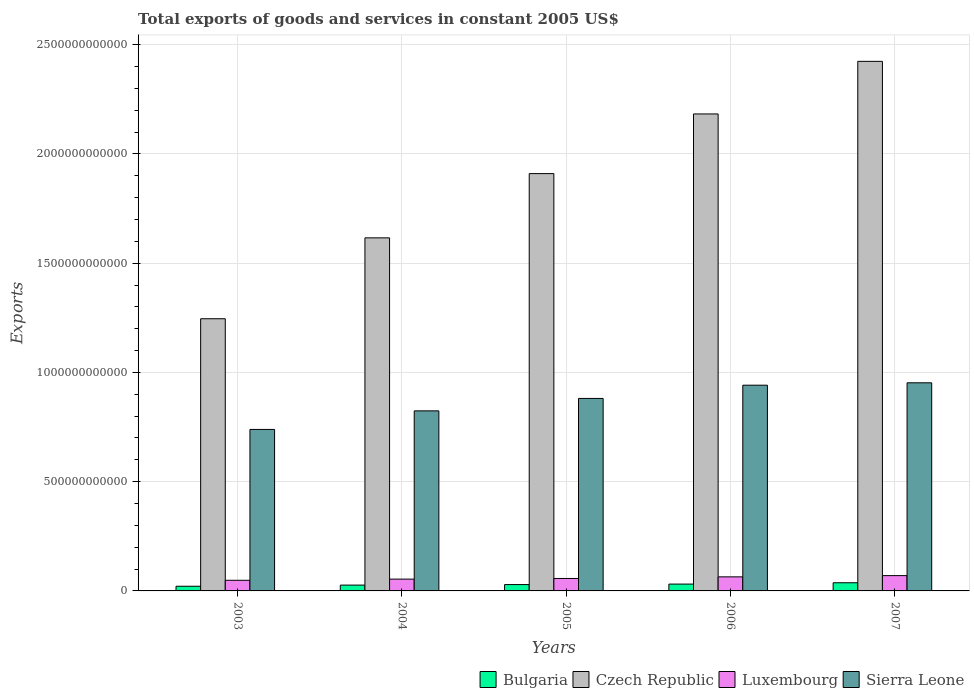How many different coloured bars are there?
Your answer should be compact. 4. How many groups of bars are there?
Make the answer very short. 5. Are the number of bars per tick equal to the number of legend labels?
Make the answer very short. Yes. Are the number of bars on each tick of the X-axis equal?
Give a very brief answer. Yes. How many bars are there on the 1st tick from the left?
Provide a succinct answer. 4. What is the label of the 5th group of bars from the left?
Make the answer very short. 2007. In how many cases, is the number of bars for a given year not equal to the number of legend labels?
Your answer should be compact. 0. What is the total exports of goods and services in Luxembourg in 2006?
Provide a succinct answer. 6.44e+1. Across all years, what is the maximum total exports of goods and services in Bulgaria?
Offer a very short reply. 3.74e+1. Across all years, what is the minimum total exports of goods and services in Bulgaria?
Give a very brief answer. 2.14e+1. In which year was the total exports of goods and services in Sierra Leone maximum?
Provide a short and direct response. 2007. What is the total total exports of goods and services in Luxembourg in the graph?
Keep it short and to the point. 2.94e+11. What is the difference between the total exports of goods and services in Czech Republic in 2004 and that in 2007?
Make the answer very short. -8.08e+11. What is the difference between the total exports of goods and services in Bulgaria in 2005 and the total exports of goods and services in Luxembourg in 2003?
Offer a terse response. -1.97e+1. What is the average total exports of goods and services in Bulgaria per year?
Give a very brief answer. 2.91e+1. In the year 2004, what is the difference between the total exports of goods and services in Czech Republic and total exports of goods and services in Bulgaria?
Provide a short and direct response. 1.59e+12. What is the ratio of the total exports of goods and services in Bulgaria in 2003 to that in 2007?
Give a very brief answer. 0.57. Is the total exports of goods and services in Luxembourg in 2003 less than that in 2006?
Keep it short and to the point. Yes. Is the difference between the total exports of goods and services in Czech Republic in 2005 and 2006 greater than the difference between the total exports of goods and services in Bulgaria in 2005 and 2006?
Keep it short and to the point. No. What is the difference between the highest and the second highest total exports of goods and services in Luxembourg?
Keep it short and to the point. 5.70e+09. What is the difference between the highest and the lowest total exports of goods and services in Czech Republic?
Offer a terse response. 1.18e+12. In how many years, is the total exports of goods and services in Sierra Leone greater than the average total exports of goods and services in Sierra Leone taken over all years?
Your response must be concise. 3. What does the 3rd bar from the left in 2004 represents?
Provide a short and direct response. Luxembourg. Are all the bars in the graph horizontal?
Give a very brief answer. No. What is the difference between two consecutive major ticks on the Y-axis?
Ensure brevity in your answer.  5.00e+11. Are the values on the major ticks of Y-axis written in scientific E-notation?
Make the answer very short. No. Does the graph contain any zero values?
Offer a very short reply. No. Does the graph contain grids?
Offer a very short reply. Yes. How many legend labels are there?
Offer a terse response. 4. What is the title of the graph?
Your answer should be compact. Total exports of goods and services in constant 2005 US$. Does "Caribbean small states" appear as one of the legend labels in the graph?
Keep it short and to the point. No. What is the label or title of the Y-axis?
Your answer should be compact. Exports. What is the Exports in Bulgaria in 2003?
Make the answer very short. 2.14e+1. What is the Exports of Czech Republic in 2003?
Provide a short and direct response. 1.25e+12. What is the Exports of Luxembourg in 2003?
Your answer should be very brief. 4.87e+1. What is the Exports of Sierra Leone in 2003?
Ensure brevity in your answer.  7.39e+11. What is the Exports in Bulgaria in 2004?
Your answer should be very brief. 2.66e+1. What is the Exports in Czech Republic in 2004?
Ensure brevity in your answer.  1.62e+12. What is the Exports of Luxembourg in 2004?
Provide a short and direct response. 5.40e+1. What is the Exports of Sierra Leone in 2004?
Provide a succinct answer. 8.24e+11. What is the Exports in Bulgaria in 2005?
Keep it short and to the point. 2.90e+1. What is the Exports of Czech Republic in 2005?
Provide a succinct answer. 1.91e+12. What is the Exports in Luxembourg in 2005?
Your response must be concise. 5.70e+1. What is the Exports of Sierra Leone in 2005?
Offer a terse response. 8.81e+11. What is the Exports in Bulgaria in 2006?
Offer a very short reply. 3.13e+1. What is the Exports in Czech Republic in 2006?
Give a very brief answer. 2.18e+12. What is the Exports in Luxembourg in 2006?
Give a very brief answer. 6.44e+1. What is the Exports of Sierra Leone in 2006?
Provide a short and direct response. 9.42e+11. What is the Exports of Bulgaria in 2007?
Keep it short and to the point. 3.74e+1. What is the Exports in Czech Republic in 2007?
Give a very brief answer. 2.42e+12. What is the Exports in Luxembourg in 2007?
Provide a succinct answer. 7.01e+1. What is the Exports of Sierra Leone in 2007?
Offer a terse response. 9.53e+11. Across all years, what is the maximum Exports in Bulgaria?
Ensure brevity in your answer.  3.74e+1. Across all years, what is the maximum Exports of Czech Republic?
Offer a very short reply. 2.42e+12. Across all years, what is the maximum Exports of Luxembourg?
Offer a very short reply. 7.01e+1. Across all years, what is the maximum Exports in Sierra Leone?
Make the answer very short. 9.53e+11. Across all years, what is the minimum Exports in Bulgaria?
Offer a very short reply. 2.14e+1. Across all years, what is the minimum Exports in Czech Republic?
Make the answer very short. 1.25e+12. Across all years, what is the minimum Exports of Luxembourg?
Keep it short and to the point. 4.87e+1. Across all years, what is the minimum Exports in Sierra Leone?
Provide a short and direct response. 7.39e+11. What is the total Exports in Bulgaria in the graph?
Your response must be concise. 1.46e+11. What is the total Exports in Czech Republic in the graph?
Provide a short and direct response. 9.38e+12. What is the total Exports of Luxembourg in the graph?
Make the answer very short. 2.94e+11. What is the total Exports of Sierra Leone in the graph?
Give a very brief answer. 4.34e+12. What is the difference between the Exports in Bulgaria in 2003 and that in 2004?
Your answer should be very brief. -5.24e+09. What is the difference between the Exports in Czech Republic in 2003 and that in 2004?
Your response must be concise. -3.70e+11. What is the difference between the Exports of Luxembourg in 2003 and that in 2004?
Keep it short and to the point. -5.30e+09. What is the difference between the Exports in Sierra Leone in 2003 and that in 2004?
Provide a succinct answer. -8.50e+1. What is the difference between the Exports in Bulgaria in 2003 and that in 2005?
Keep it short and to the point. -7.66e+09. What is the difference between the Exports in Czech Republic in 2003 and that in 2005?
Your answer should be very brief. -6.64e+11. What is the difference between the Exports in Luxembourg in 2003 and that in 2005?
Your answer should be compact. -8.27e+09. What is the difference between the Exports in Sierra Leone in 2003 and that in 2005?
Your answer should be compact. -1.42e+11. What is the difference between the Exports of Bulgaria in 2003 and that in 2006?
Ensure brevity in your answer.  -9.88e+09. What is the difference between the Exports of Czech Republic in 2003 and that in 2006?
Your answer should be very brief. -9.37e+11. What is the difference between the Exports of Luxembourg in 2003 and that in 2006?
Provide a short and direct response. -1.57e+1. What is the difference between the Exports of Sierra Leone in 2003 and that in 2006?
Your response must be concise. -2.03e+11. What is the difference between the Exports in Bulgaria in 2003 and that in 2007?
Offer a very short reply. -1.60e+1. What is the difference between the Exports in Czech Republic in 2003 and that in 2007?
Give a very brief answer. -1.18e+12. What is the difference between the Exports of Luxembourg in 2003 and that in 2007?
Offer a terse response. -2.14e+1. What is the difference between the Exports in Sierra Leone in 2003 and that in 2007?
Provide a short and direct response. -2.13e+11. What is the difference between the Exports in Bulgaria in 2004 and that in 2005?
Make the answer very short. -2.42e+09. What is the difference between the Exports of Czech Republic in 2004 and that in 2005?
Offer a terse response. -2.94e+11. What is the difference between the Exports in Luxembourg in 2004 and that in 2005?
Your answer should be compact. -2.97e+09. What is the difference between the Exports of Sierra Leone in 2004 and that in 2005?
Offer a very short reply. -5.69e+1. What is the difference between the Exports in Bulgaria in 2004 and that in 2006?
Your answer should be very brief. -4.64e+09. What is the difference between the Exports in Czech Republic in 2004 and that in 2006?
Provide a short and direct response. -5.67e+11. What is the difference between the Exports in Luxembourg in 2004 and that in 2006?
Provide a succinct answer. -1.04e+1. What is the difference between the Exports of Sierra Leone in 2004 and that in 2006?
Give a very brief answer. -1.17e+11. What is the difference between the Exports of Bulgaria in 2004 and that in 2007?
Provide a short and direct response. -1.08e+1. What is the difference between the Exports in Czech Republic in 2004 and that in 2007?
Keep it short and to the point. -8.08e+11. What is the difference between the Exports in Luxembourg in 2004 and that in 2007?
Make the answer very short. -1.61e+1. What is the difference between the Exports in Sierra Leone in 2004 and that in 2007?
Your response must be concise. -1.28e+11. What is the difference between the Exports of Bulgaria in 2005 and that in 2006?
Offer a very short reply. -2.23e+09. What is the difference between the Exports of Czech Republic in 2005 and that in 2006?
Provide a succinct answer. -2.73e+11. What is the difference between the Exports of Luxembourg in 2005 and that in 2006?
Ensure brevity in your answer.  -7.42e+09. What is the difference between the Exports of Sierra Leone in 2005 and that in 2006?
Make the answer very short. -6.06e+1. What is the difference between the Exports in Bulgaria in 2005 and that in 2007?
Give a very brief answer. -8.36e+09. What is the difference between the Exports of Czech Republic in 2005 and that in 2007?
Keep it short and to the point. -5.14e+11. What is the difference between the Exports in Luxembourg in 2005 and that in 2007?
Your answer should be compact. -1.31e+1. What is the difference between the Exports of Sierra Leone in 2005 and that in 2007?
Offer a very short reply. -7.16e+1. What is the difference between the Exports in Bulgaria in 2006 and that in 2007?
Ensure brevity in your answer.  -6.13e+09. What is the difference between the Exports of Czech Republic in 2006 and that in 2007?
Your response must be concise. -2.41e+11. What is the difference between the Exports of Luxembourg in 2006 and that in 2007?
Make the answer very short. -5.70e+09. What is the difference between the Exports in Sierra Leone in 2006 and that in 2007?
Your response must be concise. -1.10e+1. What is the difference between the Exports of Bulgaria in 2003 and the Exports of Czech Republic in 2004?
Your answer should be very brief. -1.59e+12. What is the difference between the Exports in Bulgaria in 2003 and the Exports in Luxembourg in 2004?
Your answer should be compact. -3.26e+1. What is the difference between the Exports in Bulgaria in 2003 and the Exports in Sierra Leone in 2004?
Provide a succinct answer. -8.03e+11. What is the difference between the Exports of Czech Republic in 2003 and the Exports of Luxembourg in 2004?
Make the answer very short. 1.19e+12. What is the difference between the Exports in Czech Republic in 2003 and the Exports in Sierra Leone in 2004?
Make the answer very short. 4.22e+11. What is the difference between the Exports in Luxembourg in 2003 and the Exports in Sierra Leone in 2004?
Provide a short and direct response. -7.76e+11. What is the difference between the Exports in Bulgaria in 2003 and the Exports in Czech Republic in 2005?
Your answer should be very brief. -1.89e+12. What is the difference between the Exports in Bulgaria in 2003 and the Exports in Luxembourg in 2005?
Provide a succinct answer. -3.56e+1. What is the difference between the Exports in Bulgaria in 2003 and the Exports in Sierra Leone in 2005?
Offer a very short reply. -8.60e+11. What is the difference between the Exports of Czech Republic in 2003 and the Exports of Luxembourg in 2005?
Your answer should be compact. 1.19e+12. What is the difference between the Exports of Czech Republic in 2003 and the Exports of Sierra Leone in 2005?
Make the answer very short. 3.65e+11. What is the difference between the Exports of Luxembourg in 2003 and the Exports of Sierra Leone in 2005?
Make the answer very short. -8.32e+11. What is the difference between the Exports in Bulgaria in 2003 and the Exports in Czech Republic in 2006?
Your answer should be compact. -2.16e+12. What is the difference between the Exports in Bulgaria in 2003 and the Exports in Luxembourg in 2006?
Your answer should be very brief. -4.30e+1. What is the difference between the Exports of Bulgaria in 2003 and the Exports of Sierra Leone in 2006?
Offer a very short reply. -9.20e+11. What is the difference between the Exports in Czech Republic in 2003 and the Exports in Luxembourg in 2006?
Your answer should be very brief. 1.18e+12. What is the difference between the Exports of Czech Republic in 2003 and the Exports of Sierra Leone in 2006?
Your answer should be compact. 3.04e+11. What is the difference between the Exports of Luxembourg in 2003 and the Exports of Sierra Leone in 2006?
Your answer should be compact. -8.93e+11. What is the difference between the Exports of Bulgaria in 2003 and the Exports of Czech Republic in 2007?
Your answer should be compact. -2.40e+12. What is the difference between the Exports in Bulgaria in 2003 and the Exports in Luxembourg in 2007?
Offer a very short reply. -4.87e+1. What is the difference between the Exports of Bulgaria in 2003 and the Exports of Sierra Leone in 2007?
Provide a succinct answer. -9.31e+11. What is the difference between the Exports in Czech Republic in 2003 and the Exports in Luxembourg in 2007?
Give a very brief answer. 1.18e+12. What is the difference between the Exports of Czech Republic in 2003 and the Exports of Sierra Leone in 2007?
Make the answer very short. 2.93e+11. What is the difference between the Exports of Luxembourg in 2003 and the Exports of Sierra Leone in 2007?
Keep it short and to the point. -9.04e+11. What is the difference between the Exports of Bulgaria in 2004 and the Exports of Czech Republic in 2005?
Make the answer very short. -1.88e+12. What is the difference between the Exports of Bulgaria in 2004 and the Exports of Luxembourg in 2005?
Make the answer very short. -3.03e+1. What is the difference between the Exports of Bulgaria in 2004 and the Exports of Sierra Leone in 2005?
Ensure brevity in your answer.  -8.54e+11. What is the difference between the Exports in Czech Republic in 2004 and the Exports in Luxembourg in 2005?
Your answer should be compact. 1.56e+12. What is the difference between the Exports in Czech Republic in 2004 and the Exports in Sierra Leone in 2005?
Provide a succinct answer. 7.35e+11. What is the difference between the Exports in Luxembourg in 2004 and the Exports in Sierra Leone in 2005?
Your response must be concise. -8.27e+11. What is the difference between the Exports of Bulgaria in 2004 and the Exports of Czech Republic in 2006?
Give a very brief answer. -2.16e+12. What is the difference between the Exports in Bulgaria in 2004 and the Exports in Luxembourg in 2006?
Your response must be concise. -3.78e+1. What is the difference between the Exports in Bulgaria in 2004 and the Exports in Sierra Leone in 2006?
Your answer should be compact. -9.15e+11. What is the difference between the Exports in Czech Republic in 2004 and the Exports in Luxembourg in 2006?
Your answer should be compact. 1.55e+12. What is the difference between the Exports of Czech Republic in 2004 and the Exports of Sierra Leone in 2006?
Provide a short and direct response. 6.74e+11. What is the difference between the Exports of Luxembourg in 2004 and the Exports of Sierra Leone in 2006?
Offer a very short reply. -8.88e+11. What is the difference between the Exports of Bulgaria in 2004 and the Exports of Czech Republic in 2007?
Your answer should be very brief. -2.40e+12. What is the difference between the Exports of Bulgaria in 2004 and the Exports of Luxembourg in 2007?
Keep it short and to the point. -4.35e+1. What is the difference between the Exports of Bulgaria in 2004 and the Exports of Sierra Leone in 2007?
Give a very brief answer. -9.26e+11. What is the difference between the Exports of Czech Republic in 2004 and the Exports of Luxembourg in 2007?
Offer a terse response. 1.55e+12. What is the difference between the Exports in Czech Republic in 2004 and the Exports in Sierra Leone in 2007?
Give a very brief answer. 6.63e+11. What is the difference between the Exports of Luxembourg in 2004 and the Exports of Sierra Leone in 2007?
Your answer should be very brief. -8.99e+11. What is the difference between the Exports in Bulgaria in 2005 and the Exports in Czech Republic in 2006?
Provide a succinct answer. -2.15e+12. What is the difference between the Exports in Bulgaria in 2005 and the Exports in Luxembourg in 2006?
Your response must be concise. -3.53e+1. What is the difference between the Exports of Bulgaria in 2005 and the Exports of Sierra Leone in 2006?
Offer a terse response. -9.13e+11. What is the difference between the Exports in Czech Republic in 2005 and the Exports in Luxembourg in 2006?
Provide a succinct answer. 1.85e+12. What is the difference between the Exports in Czech Republic in 2005 and the Exports in Sierra Leone in 2006?
Provide a short and direct response. 9.68e+11. What is the difference between the Exports in Luxembourg in 2005 and the Exports in Sierra Leone in 2006?
Your answer should be compact. -8.85e+11. What is the difference between the Exports of Bulgaria in 2005 and the Exports of Czech Republic in 2007?
Your answer should be very brief. -2.39e+12. What is the difference between the Exports in Bulgaria in 2005 and the Exports in Luxembourg in 2007?
Make the answer very short. -4.10e+1. What is the difference between the Exports of Bulgaria in 2005 and the Exports of Sierra Leone in 2007?
Provide a succinct answer. -9.24e+11. What is the difference between the Exports in Czech Republic in 2005 and the Exports in Luxembourg in 2007?
Your answer should be compact. 1.84e+12. What is the difference between the Exports of Czech Republic in 2005 and the Exports of Sierra Leone in 2007?
Ensure brevity in your answer.  9.58e+11. What is the difference between the Exports in Luxembourg in 2005 and the Exports in Sierra Leone in 2007?
Your answer should be compact. -8.96e+11. What is the difference between the Exports of Bulgaria in 2006 and the Exports of Czech Republic in 2007?
Ensure brevity in your answer.  -2.39e+12. What is the difference between the Exports in Bulgaria in 2006 and the Exports in Luxembourg in 2007?
Keep it short and to the point. -3.88e+1. What is the difference between the Exports in Bulgaria in 2006 and the Exports in Sierra Leone in 2007?
Your response must be concise. -9.21e+11. What is the difference between the Exports in Czech Republic in 2006 and the Exports in Luxembourg in 2007?
Your answer should be compact. 2.11e+12. What is the difference between the Exports of Czech Republic in 2006 and the Exports of Sierra Leone in 2007?
Provide a succinct answer. 1.23e+12. What is the difference between the Exports of Luxembourg in 2006 and the Exports of Sierra Leone in 2007?
Keep it short and to the point. -8.88e+11. What is the average Exports of Bulgaria per year?
Provide a succinct answer. 2.91e+1. What is the average Exports of Czech Republic per year?
Your response must be concise. 1.88e+12. What is the average Exports of Luxembourg per year?
Make the answer very short. 5.88e+1. What is the average Exports of Sierra Leone per year?
Offer a very short reply. 8.68e+11. In the year 2003, what is the difference between the Exports of Bulgaria and Exports of Czech Republic?
Keep it short and to the point. -1.22e+12. In the year 2003, what is the difference between the Exports of Bulgaria and Exports of Luxembourg?
Ensure brevity in your answer.  -2.73e+1. In the year 2003, what is the difference between the Exports in Bulgaria and Exports in Sierra Leone?
Provide a succinct answer. -7.18e+11. In the year 2003, what is the difference between the Exports in Czech Republic and Exports in Luxembourg?
Make the answer very short. 1.20e+12. In the year 2003, what is the difference between the Exports in Czech Republic and Exports in Sierra Leone?
Offer a terse response. 5.07e+11. In the year 2003, what is the difference between the Exports in Luxembourg and Exports in Sierra Leone?
Provide a succinct answer. -6.90e+11. In the year 2004, what is the difference between the Exports of Bulgaria and Exports of Czech Republic?
Keep it short and to the point. -1.59e+12. In the year 2004, what is the difference between the Exports of Bulgaria and Exports of Luxembourg?
Offer a very short reply. -2.74e+1. In the year 2004, what is the difference between the Exports in Bulgaria and Exports in Sierra Leone?
Offer a terse response. -7.98e+11. In the year 2004, what is the difference between the Exports of Czech Republic and Exports of Luxembourg?
Give a very brief answer. 1.56e+12. In the year 2004, what is the difference between the Exports of Czech Republic and Exports of Sierra Leone?
Your answer should be compact. 7.92e+11. In the year 2004, what is the difference between the Exports of Luxembourg and Exports of Sierra Leone?
Offer a terse response. -7.70e+11. In the year 2005, what is the difference between the Exports in Bulgaria and Exports in Czech Republic?
Make the answer very short. -1.88e+12. In the year 2005, what is the difference between the Exports of Bulgaria and Exports of Luxembourg?
Make the answer very short. -2.79e+1. In the year 2005, what is the difference between the Exports in Bulgaria and Exports in Sierra Leone?
Ensure brevity in your answer.  -8.52e+11. In the year 2005, what is the difference between the Exports in Czech Republic and Exports in Luxembourg?
Your answer should be very brief. 1.85e+12. In the year 2005, what is the difference between the Exports in Czech Republic and Exports in Sierra Leone?
Your answer should be compact. 1.03e+12. In the year 2005, what is the difference between the Exports in Luxembourg and Exports in Sierra Leone?
Ensure brevity in your answer.  -8.24e+11. In the year 2006, what is the difference between the Exports in Bulgaria and Exports in Czech Republic?
Offer a terse response. -2.15e+12. In the year 2006, what is the difference between the Exports of Bulgaria and Exports of Luxembourg?
Keep it short and to the point. -3.31e+1. In the year 2006, what is the difference between the Exports of Bulgaria and Exports of Sierra Leone?
Make the answer very short. -9.10e+11. In the year 2006, what is the difference between the Exports in Czech Republic and Exports in Luxembourg?
Your answer should be very brief. 2.12e+12. In the year 2006, what is the difference between the Exports of Czech Republic and Exports of Sierra Leone?
Offer a very short reply. 1.24e+12. In the year 2006, what is the difference between the Exports in Luxembourg and Exports in Sierra Leone?
Your answer should be compact. -8.77e+11. In the year 2007, what is the difference between the Exports in Bulgaria and Exports in Czech Republic?
Provide a succinct answer. -2.39e+12. In the year 2007, what is the difference between the Exports in Bulgaria and Exports in Luxembourg?
Give a very brief answer. -3.27e+1. In the year 2007, what is the difference between the Exports of Bulgaria and Exports of Sierra Leone?
Offer a terse response. -9.15e+11. In the year 2007, what is the difference between the Exports of Czech Republic and Exports of Luxembourg?
Make the answer very short. 2.35e+12. In the year 2007, what is the difference between the Exports in Czech Republic and Exports in Sierra Leone?
Your answer should be very brief. 1.47e+12. In the year 2007, what is the difference between the Exports of Luxembourg and Exports of Sierra Leone?
Your answer should be very brief. -8.83e+11. What is the ratio of the Exports in Bulgaria in 2003 to that in 2004?
Keep it short and to the point. 0.8. What is the ratio of the Exports of Czech Republic in 2003 to that in 2004?
Offer a very short reply. 0.77. What is the ratio of the Exports of Luxembourg in 2003 to that in 2004?
Make the answer very short. 0.9. What is the ratio of the Exports in Sierra Leone in 2003 to that in 2004?
Your answer should be very brief. 0.9. What is the ratio of the Exports in Bulgaria in 2003 to that in 2005?
Keep it short and to the point. 0.74. What is the ratio of the Exports in Czech Republic in 2003 to that in 2005?
Offer a very short reply. 0.65. What is the ratio of the Exports in Luxembourg in 2003 to that in 2005?
Offer a terse response. 0.85. What is the ratio of the Exports in Sierra Leone in 2003 to that in 2005?
Your response must be concise. 0.84. What is the ratio of the Exports of Bulgaria in 2003 to that in 2006?
Make the answer very short. 0.68. What is the ratio of the Exports in Czech Republic in 2003 to that in 2006?
Offer a very short reply. 0.57. What is the ratio of the Exports of Luxembourg in 2003 to that in 2006?
Your answer should be compact. 0.76. What is the ratio of the Exports in Sierra Leone in 2003 to that in 2006?
Your response must be concise. 0.79. What is the ratio of the Exports of Bulgaria in 2003 to that in 2007?
Ensure brevity in your answer.  0.57. What is the ratio of the Exports in Czech Republic in 2003 to that in 2007?
Provide a short and direct response. 0.51. What is the ratio of the Exports of Luxembourg in 2003 to that in 2007?
Keep it short and to the point. 0.69. What is the ratio of the Exports in Sierra Leone in 2003 to that in 2007?
Your answer should be very brief. 0.78. What is the ratio of the Exports in Bulgaria in 2004 to that in 2005?
Ensure brevity in your answer.  0.92. What is the ratio of the Exports of Czech Republic in 2004 to that in 2005?
Your response must be concise. 0.85. What is the ratio of the Exports in Luxembourg in 2004 to that in 2005?
Your answer should be very brief. 0.95. What is the ratio of the Exports of Sierra Leone in 2004 to that in 2005?
Offer a terse response. 0.94. What is the ratio of the Exports in Bulgaria in 2004 to that in 2006?
Ensure brevity in your answer.  0.85. What is the ratio of the Exports of Czech Republic in 2004 to that in 2006?
Provide a succinct answer. 0.74. What is the ratio of the Exports of Luxembourg in 2004 to that in 2006?
Make the answer very short. 0.84. What is the ratio of the Exports in Sierra Leone in 2004 to that in 2006?
Keep it short and to the point. 0.88. What is the ratio of the Exports in Bulgaria in 2004 to that in 2007?
Your answer should be compact. 0.71. What is the ratio of the Exports in Czech Republic in 2004 to that in 2007?
Provide a short and direct response. 0.67. What is the ratio of the Exports of Luxembourg in 2004 to that in 2007?
Ensure brevity in your answer.  0.77. What is the ratio of the Exports in Sierra Leone in 2004 to that in 2007?
Provide a short and direct response. 0.87. What is the ratio of the Exports of Bulgaria in 2005 to that in 2006?
Provide a succinct answer. 0.93. What is the ratio of the Exports of Czech Republic in 2005 to that in 2006?
Your response must be concise. 0.87. What is the ratio of the Exports of Luxembourg in 2005 to that in 2006?
Provide a succinct answer. 0.88. What is the ratio of the Exports of Sierra Leone in 2005 to that in 2006?
Your response must be concise. 0.94. What is the ratio of the Exports in Bulgaria in 2005 to that in 2007?
Your answer should be very brief. 0.78. What is the ratio of the Exports in Czech Republic in 2005 to that in 2007?
Keep it short and to the point. 0.79. What is the ratio of the Exports of Luxembourg in 2005 to that in 2007?
Your response must be concise. 0.81. What is the ratio of the Exports of Sierra Leone in 2005 to that in 2007?
Give a very brief answer. 0.92. What is the ratio of the Exports in Bulgaria in 2006 to that in 2007?
Your response must be concise. 0.84. What is the ratio of the Exports in Czech Republic in 2006 to that in 2007?
Your response must be concise. 0.9. What is the ratio of the Exports in Luxembourg in 2006 to that in 2007?
Your response must be concise. 0.92. What is the difference between the highest and the second highest Exports of Bulgaria?
Offer a terse response. 6.13e+09. What is the difference between the highest and the second highest Exports of Czech Republic?
Keep it short and to the point. 2.41e+11. What is the difference between the highest and the second highest Exports of Luxembourg?
Ensure brevity in your answer.  5.70e+09. What is the difference between the highest and the second highest Exports of Sierra Leone?
Keep it short and to the point. 1.10e+1. What is the difference between the highest and the lowest Exports in Bulgaria?
Ensure brevity in your answer.  1.60e+1. What is the difference between the highest and the lowest Exports of Czech Republic?
Provide a succinct answer. 1.18e+12. What is the difference between the highest and the lowest Exports in Luxembourg?
Offer a terse response. 2.14e+1. What is the difference between the highest and the lowest Exports in Sierra Leone?
Your response must be concise. 2.13e+11. 